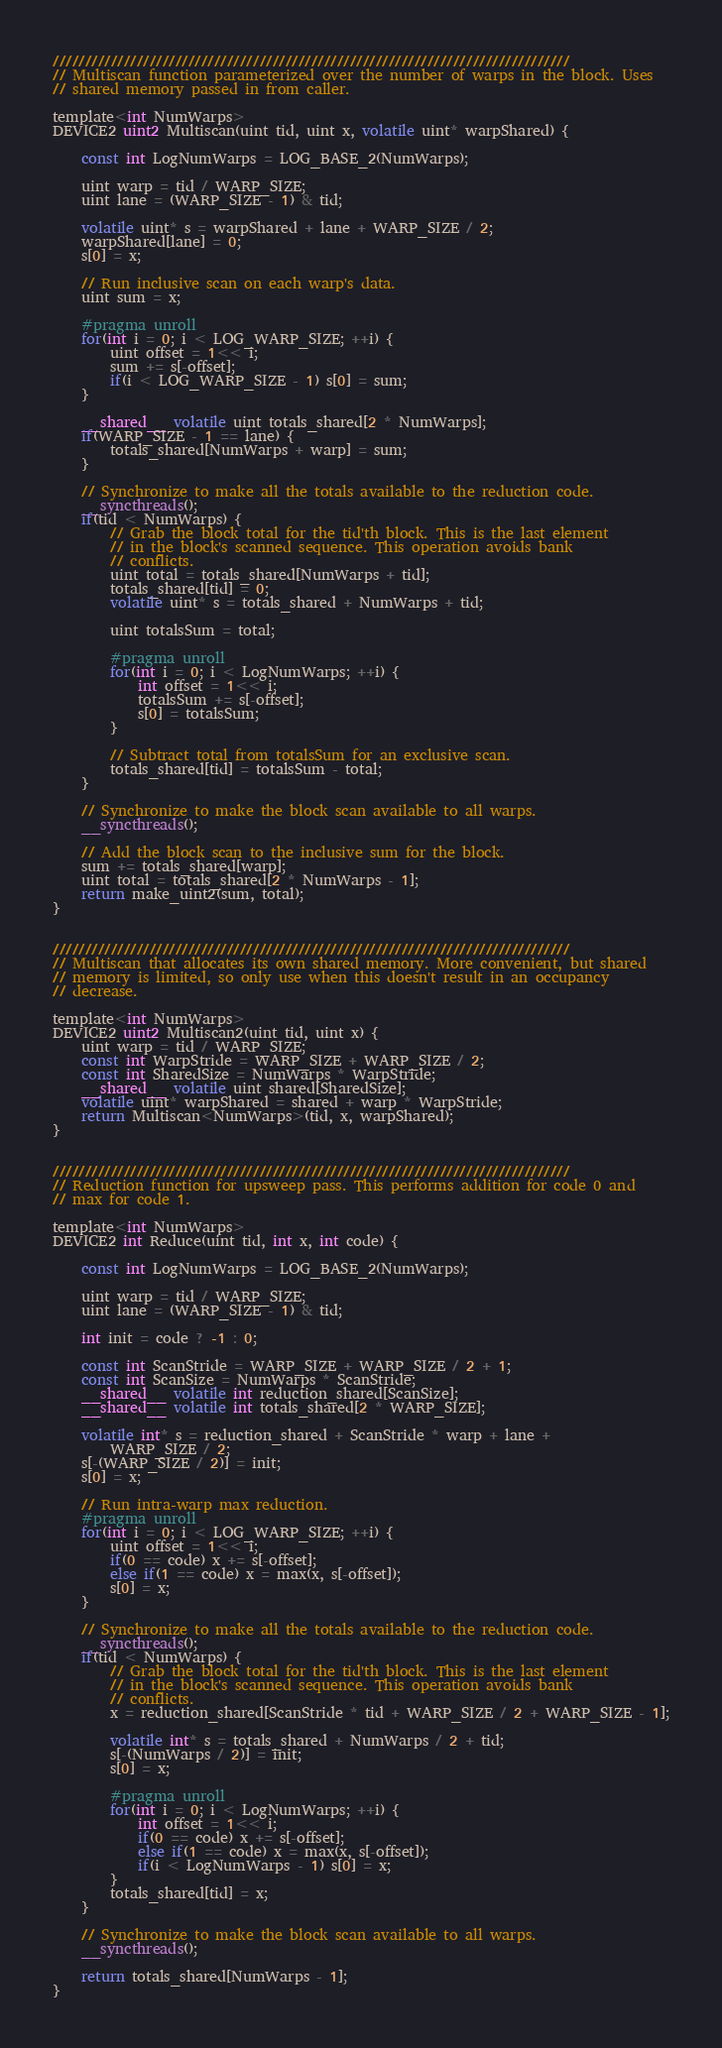<code> <loc_0><loc_0><loc_500><loc_500><_Cuda_>
////////////////////////////////////////////////////////////////////////////////
// Multiscan function parameterized over the number of warps in the block. Uses
// shared memory passed in from caller.

template<int NumWarps>
DEVICE2 uint2 Multiscan(uint tid, uint x, volatile uint* warpShared) {

	const int LogNumWarps = LOG_BASE_2(NumWarps);
		
	uint warp = tid / WARP_SIZE;
	uint lane = (WARP_SIZE - 1) & tid;

	volatile uint* s = warpShared + lane + WARP_SIZE / 2;
	warpShared[lane] = 0;
	s[0] = x;

	// Run inclusive scan on each warp's data.
	uint sum = x;

	#pragma unroll
	for(int i = 0; i < LOG_WARP_SIZE; ++i) {
		uint offset = 1<< i;
		sum += s[-offset];
		if(i < LOG_WARP_SIZE - 1) s[0] = sum;
	}

	__shared__ volatile uint totals_shared[2 * NumWarps];
	if(WARP_SIZE - 1 == lane) {
		totals_shared[NumWarps + warp] = sum;
	}

	// Synchronize to make all the totals available to the reduction code.
	__syncthreads();
	if(tid < NumWarps) {
		// Grab the block total for the tid'th block. This is the last element
		// in the block's scanned sequence. This operation avoids bank 
		// conflicts.
		uint total = totals_shared[NumWarps + tid];
		totals_shared[tid] = 0;
		volatile uint* s = totals_shared + NumWarps + tid;

		uint totalsSum = total;

		#pragma unroll
		for(int i = 0; i < LogNumWarps; ++i) {
			int offset = 1<< i;
			totalsSum += s[-offset];
			s[0] = totalsSum;	
		}

		// Subtract total from totalsSum for an exclusive scan.
		totals_shared[tid] = totalsSum - total;
	}

	// Synchronize to make the block scan available to all warps.
	__syncthreads();

	// Add the block scan to the inclusive sum for the block.
	sum += totals_shared[warp];
	uint total = totals_shared[2 * NumWarps - 1];
	return make_uint2(sum, total);
}


////////////////////////////////////////////////////////////////////////////////
// Multiscan that allocates its own shared memory. More convenient, but shared
// memory is limited, so only use when this doesn't result in an occupancy 
// decrease.

template<int NumWarps>
DEVICE2 uint2 Multiscan2(uint tid, uint x) {
	uint warp = tid / WARP_SIZE;
	const int WarpStride = WARP_SIZE + WARP_SIZE / 2;
	const int SharedSize = NumWarps * WarpStride;
	__shared__ volatile uint shared[SharedSize];
	volatile uint* warpShared = shared + warp * WarpStride;
	return Multiscan<NumWarps>(tid, x, warpShared);
}


////////////////////////////////////////////////////////////////////////////////
// Reduction function for upsweep pass. This performs addition for code 0 and
// max for code 1.

template<int NumWarps>
DEVICE2 int Reduce(uint tid, int x, int code) {

	const int LogNumWarps = LOG_BASE_2(NumWarps);

	uint warp = tid / WARP_SIZE;
	uint lane = (WARP_SIZE - 1) & tid;

	int init = code ? -1 : 0;

	const int ScanStride = WARP_SIZE + WARP_SIZE / 2 + 1;
	const int ScanSize = NumWarps * ScanStride;
	__shared__ volatile int reduction_shared[ScanSize];
	__shared__ volatile int totals_shared[2 * WARP_SIZE];

	volatile int* s = reduction_shared + ScanStride * warp + lane +
		WARP_SIZE / 2;
	s[-(WARP_SIZE / 2)] = init;
	s[0] = x;

	// Run intra-warp max reduction.
	#pragma unroll
	for(int i = 0; i < LOG_WARP_SIZE; ++i) {
		uint offset = 1<< i;
		if(0 == code) x += s[-offset];
		else if(1 == code) x = max(x, s[-offset]);
		s[0] = x;
	}

	// Synchronize to make all the totals available to the reduction code.
	__syncthreads();
	if(tid < NumWarps) {
		// Grab the block total for the tid'th block. This is the last element
		// in the block's scanned sequence. This operation avoids bank 
		// conflicts.
		x = reduction_shared[ScanStride * tid + WARP_SIZE / 2 + WARP_SIZE - 1];

		volatile int* s = totals_shared + NumWarps / 2 + tid;
		s[-(NumWarps / 2)] = init;
		s[0] = x;

		#pragma unroll
		for(int i = 0; i < LogNumWarps; ++i) {
			int offset = 1<< i;
			if(0 == code) x += s[-offset];
			else if(1 == code) x = max(x, s[-offset]);
			if(i < LogNumWarps - 1) s[0] = x;
		}
		totals_shared[tid] = x;
	}

	// Synchronize to make the block scan available to all warps.
	__syncthreads();

	return totals_shared[NumWarps - 1];
}


</code> 